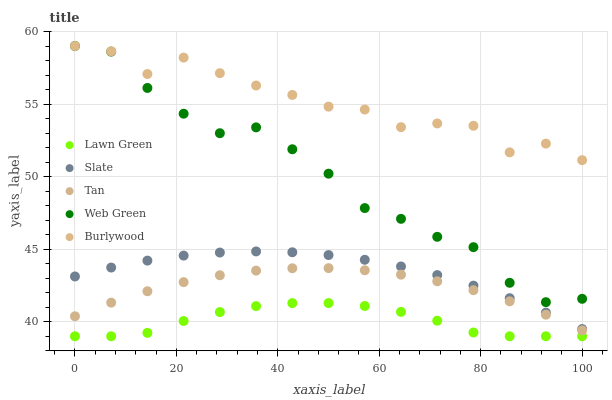Does Lawn Green have the minimum area under the curve?
Answer yes or no. Yes. Does Burlywood have the maximum area under the curve?
Answer yes or no. Yes. Does Slate have the minimum area under the curve?
Answer yes or no. No. Does Slate have the maximum area under the curve?
Answer yes or no. No. Is Slate the smoothest?
Answer yes or no. Yes. Is Burlywood the roughest?
Answer yes or no. Yes. Is Lawn Green the smoothest?
Answer yes or no. No. Is Lawn Green the roughest?
Answer yes or no. No. Does Lawn Green have the lowest value?
Answer yes or no. Yes. Does Slate have the lowest value?
Answer yes or no. No. Does Web Green have the highest value?
Answer yes or no. Yes. Does Slate have the highest value?
Answer yes or no. No. Is Tan less than Slate?
Answer yes or no. Yes. Is Web Green greater than Tan?
Answer yes or no. Yes. Does Web Green intersect Burlywood?
Answer yes or no. Yes. Is Web Green less than Burlywood?
Answer yes or no. No. Is Web Green greater than Burlywood?
Answer yes or no. No. Does Tan intersect Slate?
Answer yes or no. No. 